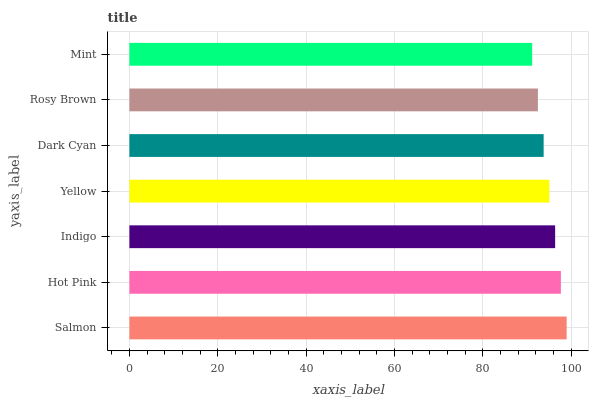Is Mint the minimum?
Answer yes or no. Yes. Is Salmon the maximum?
Answer yes or no. Yes. Is Hot Pink the minimum?
Answer yes or no. No. Is Hot Pink the maximum?
Answer yes or no. No. Is Salmon greater than Hot Pink?
Answer yes or no. Yes. Is Hot Pink less than Salmon?
Answer yes or no. Yes. Is Hot Pink greater than Salmon?
Answer yes or no. No. Is Salmon less than Hot Pink?
Answer yes or no. No. Is Yellow the high median?
Answer yes or no. Yes. Is Yellow the low median?
Answer yes or no. Yes. Is Salmon the high median?
Answer yes or no. No. Is Indigo the low median?
Answer yes or no. No. 